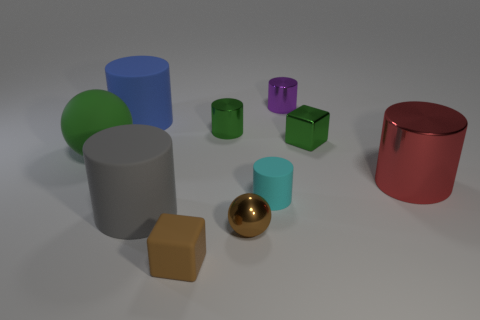Are there any small balls that have the same color as the tiny rubber block?
Offer a very short reply. Yes. Is there a gray metal thing?
Your response must be concise. No. What material is the green thing that is in front of the tiny green metal cylinder and on the right side of the blue cylinder?
Provide a short and direct response. Metal. Is the number of cyan things behind the small green block greater than the number of brown matte objects that are behind the small green metal cylinder?
Keep it short and to the point. No. Are there any cyan spheres of the same size as the purple cylinder?
Give a very brief answer. No. What size is the shiny cylinder behind the small green cylinder behind the sphere behind the gray matte thing?
Make the answer very short. Small. What is the color of the rubber ball?
Your answer should be compact. Green. Is the number of cyan cylinders that are in front of the gray cylinder greater than the number of big yellow matte spheres?
Keep it short and to the point. No. There is a green shiny cube; what number of brown things are to the right of it?
Keep it short and to the point. 0. What is the shape of the tiny object that is the same color as the tiny matte cube?
Ensure brevity in your answer.  Sphere. 